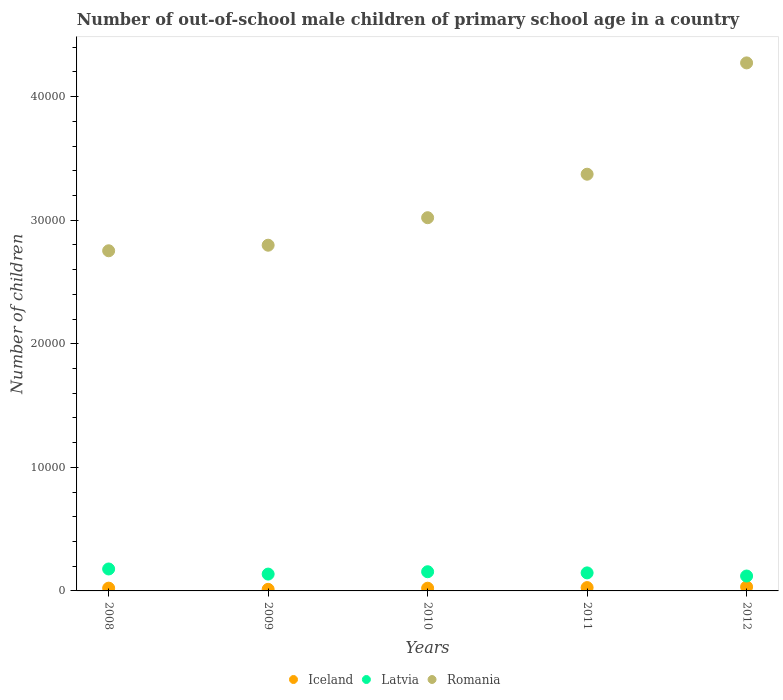Is the number of dotlines equal to the number of legend labels?
Ensure brevity in your answer.  Yes. What is the number of out-of-school male children in Latvia in 2011?
Make the answer very short. 1459. Across all years, what is the maximum number of out-of-school male children in Iceland?
Offer a terse response. 327. Across all years, what is the minimum number of out-of-school male children in Romania?
Offer a very short reply. 2.75e+04. In which year was the number of out-of-school male children in Iceland maximum?
Your response must be concise. 2012. In which year was the number of out-of-school male children in Romania minimum?
Make the answer very short. 2008. What is the total number of out-of-school male children in Iceland in the graph?
Offer a terse response. 1170. What is the difference between the number of out-of-school male children in Romania in 2009 and that in 2012?
Give a very brief answer. -1.48e+04. What is the difference between the number of out-of-school male children in Romania in 2010 and the number of out-of-school male children in Latvia in 2009?
Ensure brevity in your answer.  2.88e+04. What is the average number of out-of-school male children in Iceland per year?
Ensure brevity in your answer.  234. In the year 2008, what is the difference between the number of out-of-school male children in Romania and number of out-of-school male children in Iceland?
Your response must be concise. 2.73e+04. What is the ratio of the number of out-of-school male children in Latvia in 2009 to that in 2010?
Your answer should be very brief. 0.88. Is the difference between the number of out-of-school male children in Romania in 2009 and 2010 greater than the difference between the number of out-of-school male children in Iceland in 2009 and 2010?
Offer a very short reply. No. What is the difference between the highest and the second highest number of out-of-school male children in Latvia?
Your answer should be very brief. 224. What is the difference between the highest and the lowest number of out-of-school male children in Iceland?
Your answer should be compact. 198. Does the number of out-of-school male children in Iceland monotonically increase over the years?
Your answer should be very brief. No. Is the number of out-of-school male children in Romania strictly less than the number of out-of-school male children in Iceland over the years?
Provide a succinct answer. No. How many dotlines are there?
Your answer should be very brief. 3. How many legend labels are there?
Make the answer very short. 3. How are the legend labels stacked?
Your answer should be very brief. Horizontal. What is the title of the graph?
Give a very brief answer. Number of out-of-school male children of primary school age in a country. What is the label or title of the Y-axis?
Provide a short and direct response. Number of children. What is the Number of children of Iceland in 2008?
Offer a terse response. 225. What is the Number of children in Latvia in 2008?
Your answer should be compact. 1776. What is the Number of children in Romania in 2008?
Your answer should be compact. 2.75e+04. What is the Number of children in Iceland in 2009?
Provide a succinct answer. 129. What is the Number of children in Latvia in 2009?
Your response must be concise. 1362. What is the Number of children of Romania in 2009?
Give a very brief answer. 2.80e+04. What is the Number of children in Iceland in 2010?
Your response must be concise. 219. What is the Number of children in Latvia in 2010?
Your response must be concise. 1552. What is the Number of children of Romania in 2010?
Keep it short and to the point. 3.02e+04. What is the Number of children in Iceland in 2011?
Offer a terse response. 270. What is the Number of children of Latvia in 2011?
Make the answer very short. 1459. What is the Number of children of Romania in 2011?
Make the answer very short. 3.37e+04. What is the Number of children of Iceland in 2012?
Provide a short and direct response. 327. What is the Number of children of Latvia in 2012?
Your answer should be compact. 1206. What is the Number of children of Romania in 2012?
Make the answer very short. 4.27e+04. Across all years, what is the maximum Number of children in Iceland?
Offer a very short reply. 327. Across all years, what is the maximum Number of children of Latvia?
Provide a short and direct response. 1776. Across all years, what is the maximum Number of children in Romania?
Give a very brief answer. 4.27e+04. Across all years, what is the minimum Number of children of Iceland?
Give a very brief answer. 129. Across all years, what is the minimum Number of children of Latvia?
Provide a short and direct response. 1206. Across all years, what is the minimum Number of children of Romania?
Keep it short and to the point. 2.75e+04. What is the total Number of children of Iceland in the graph?
Your answer should be compact. 1170. What is the total Number of children in Latvia in the graph?
Keep it short and to the point. 7355. What is the total Number of children of Romania in the graph?
Ensure brevity in your answer.  1.62e+05. What is the difference between the Number of children in Iceland in 2008 and that in 2009?
Give a very brief answer. 96. What is the difference between the Number of children of Latvia in 2008 and that in 2009?
Provide a short and direct response. 414. What is the difference between the Number of children of Romania in 2008 and that in 2009?
Provide a short and direct response. -450. What is the difference between the Number of children in Latvia in 2008 and that in 2010?
Your answer should be compact. 224. What is the difference between the Number of children of Romania in 2008 and that in 2010?
Provide a short and direct response. -2675. What is the difference between the Number of children of Iceland in 2008 and that in 2011?
Your response must be concise. -45. What is the difference between the Number of children in Latvia in 2008 and that in 2011?
Your response must be concise. 317. What is the difference between the Number of children in Romania in 2008 and that in 2011?
Offer a very short reply. -6195. What is the difference between the Number of children in Iceland in 2008 and that in 2012?
Keep it short and to the point. -102. What is the difference between the Number of children in Latvia in 2008 and that in 2012?
Provide a short and direct response. 570. What is the difference between the Number of children in Romania in 2008 and that in 2012?
Offer a very short reply. -1.52e+04. What is the difference between the Number of children of Iceland in 2009 and that in 2010?
Your response must be concise. -90. What is the difference between the Number of children in Latvia in 2009 and that in 2010?
Offer a very short reply. -190. What is the difference between the Number of children in Romania in 2009 and that in 2010?
Offer a terse response. -2225. What is the difference between the Number of children of Iceland in 2009 and that in 2011?
Offer a very short reply. -141. What is the difference between the Number of children of Latvia in 2009 and that in 2011?
Give a very brief answer. -97. What is the difference between the Number of children in Romania in 2009 and that in 2011?
Give a very brief answer. -5745. What is the difference between the Number of children of Iceland in 2009 and that in 2012?
Offer a terse response. -198. What is the difference between the Number of children of Latvia in 2009 and that in 2012?
Ensure brevity in your answer.  156. What is the difference between the Number of children in Romania in 2009 and that in 2012?
Give a very brief answer. -1.48e+04. What is the difference between the Number of children of Iceland in 2010 and that in 2011?
Offer a very short reply. -51. What is the difference between the Number of children in Latvia in 2010 and that in 2011?
Ensure brevity in your answer.  93. What is the difference between the Number of children in Romania in 2010 and that in 2011?
Provide a succinct answer. -3520. What is the difference between the Number of children in Iceland in 2010 and that in 2012?
Your answer should be compact. -108. What is the difference between the Number of children in Latvia in 2010 and that in 2012?
Ensure brevity in your answer.  346. What is the difference between the Number of children in Romania in 2010 and that in 2012?
Offer a very short reply. -1.25e+04. What is the difference between the Number of children in Iceland in 2011 and that in 2012?
Make the answer very short. -57. What is the difference between the Number of children in Latvia in 2011 and that in 2012?
Your answer should be very brief. 253. What is the difference between the Number of children of Romania in 2011 and that in 2012?
Keep it short and to the point. -9007. What is the difference between the Number of children of Iceland in 2008 and the Number of children of Latvia in 2009?
Offer a very short reply. -1137. What is the difference between the Number of children in Iceland in 2008 and the Number of children in Romania in 2009?
Make the answer very short. -2.77e+04. What is the difference between the Number of children of Latvia in 2008 and the Number of children of Romania in 2009?
Provide a succinct answer. -2.62e+04. What is the difference between the Number of children of Iceland in 2008 and the Number of children of Latvia in 2010?
Make the answer very short. -1327. What is the difference between the Number of children in Iceland in 2008 and the Number of children in Romania in 2010?
Provide a succinct answer. -3.00e+04. What is the difference between the Number of children of Latvia in 2008 and the Number of children of Romania in 2010?
Your response must be concise. -2.84e+04. What is the difference between the Number of children of Iceland in 2008 and the Number of children of Latvia in 2011?
Offer a very short reply. -1234. What is the difference between the Number of children of Iceland in 2008 and the Number of children of Romania in 2011?
Your response must be concise. -3.35e+04. What is the difference between the Number of children in Latvia in 2008 and the Number of children in Romania in 2011?
Make the answer very short. -3.19e+04. What is the difference between the Number of children in Iceland in 2008 and the Number of children in Latvia in 2012?
Your answer should be very brief. -981. What is the difference between the Number of children in Iceland in 2008 and the Number of children in Romania in 2012?
Provide a short and direct response. -4.25e+04. What is the difference between the Number of children in Latvia in 2008 and the Number of children in Romania in 2012?
Your answer should be compact. -4.10e+04. What is the difference between the Number of children in Iceland in 2009 and the Number of children in Latvia in 2010?
Ensure brevity in your answer.  -1423. What is the difference between the Number of children of Iceland in 2009 and the Number of children of Romania in 2010?
Keep it short and to the point. -3.01e+04. What is the difference between the Number of children of Latvia in 2009 and the Number of children of Romania in 2010?
Ensure brevity in your answer.  -2.88e+04. What is the difference between the Number of children of Iceland in 2009 and the Number of children of Latvia in 2011?
Give a very brief answer. -1330. What is the difference between the Number of children in Iceland in 2009 and the Number of children in Romania in 2011?
Your answer should be compact. -3.36e+04. What is the difference between the Number of children in Latvia in 2009 and the Number of children in Romania in 2011?
Ensure brevity in your answer.  -3.24e+04. What is the difference between the Number of children of Iceland in 2009 and the Number of children of Latvia in 2012?
Ensure brevity in your answer.  -1077. What is the difference between the Number of children of Iceland in 2009 and the Number of children of Romania in 2012?
Keep it short and to the point. -4.26e+04. What is the difference between the Number of children in Latvia in 2009 and the Number of children in Romania in 2012?
Make the answer very short. -4.14e+04. What is the difference between the Number of children of Iceland in 2010 and the Number of children of Latvia in 2011?
Make the answer very short. -1240. What is the difference between the Number of children in Iceland in 2010 and the Number of children in Romania in 2011?
Make the answer very short. -3.35e+04. What is the difference between the Number of children of Latvia in 2010 and the Number of children of Romania in 2011?
Offer a terse response. -3.22e+04. What is the difference between the Number of children of Iceland in 2010 and the Number of children of Latvia in 2012?
Provide a succinct answer. -987. What is the difference between the Number of children in Iceland in 2010 and the Number of children in Romania in 2012?
Provide a short and direct response. -4.25e+04. What is the difference between the Number of children of Latvia in 2010 and the Number of children of Romania in 2012?
Offer a terse response. -4.12e+04. What is the difference between the Number of children of Iceland in 2011 and the Number of children of Latvia in 2012?
Offer a terse response. -936. What is the difference between the Number of children in Iceland in 2011 and the Number of children in Romania in 2012?
Give a very brief answer. -4.25e+04. What is the difference between the Number of children of Latvia in 2011 and the Number of children of Romania in 2012?
Your response must be concise. -4.13e+04. What is the average Number of children in Iceland per year?
Keep it short and to the point. 234. What is the average Number of children of Latvia per year?
Keep it short and to the point. 1471. What is the average Number of children in Romania per year?
Provide a short and direct response. 3.24e+04. In the year 2008, what is the difference between the Number of children of Iceland and Number of children of Latvia?
Your answer should be compact. -1551. In the year 2008, what is the difference between the Number of children of Iceland and Number of children of Romania?
Keep it short and to the point. -2.73e+04. In the year 2008, what is the difference between the Number of children of Latvia and Number of children of Romania?
Ensure brevity in your answer.  -2.57e+04. In the year 2009, what is the difference between the Number of children of Iceland and Number of children of Latvia?
Make the answer very short. -1233. In the year 2009, what is the difference between the Number of children in Iceland and Number of children in Romania?
Ensure brevity in your answer.  -2.78e+04. In the year 2009, what is the difference between the Number of children in Latvia and Number of children in Romania?
Give a very brief answer. -2.66e+04. In the year 2010, what is the difference between the Number of children of Iceland and Number of children of Latvia?
Keep it short and to the point. -1333. In the year 2010, what is the difference between the Number of children of Iceland and Number of children of Romania?
Your answer should be compact. -3.00e+04. In the year 2010, what is the difference between the Number of children of Latvia and Number of children of Romania?
Offer a very short reply. -2.86e+04. In the year 2011, what is the difference between the Number of children of Iceland and Number of children of Latvia?
Provide a succinct answer. -1189. In the year 2011, what is the difference between the Number of children of Iceland and Number of children of Romania?
Offer a very short reply. -3.34e+04. In the year 2011, what is the difference between the Number of children of Latvia and Number of children of Romania?
Provide a succinct answer. -3.23e+04. In the year 2012, what is the difference between the Number of children of Iceland and Number of children of Latvia?
Make the answer very short. -879. In the year 2012, what is the difference between the Number of children in Iceland and Number of children in Romania?
Your answer should be very brief. -4.24e+04. In the year 2012, what is the difference between the Number of children of Latvia and Number of children of Romania?
Provide a short and direct response. -4.15e+04. What is the ratio of the Number of children of Iceland in 2008 to that in 2009?
Ensure brevity in your answer.  1.74. What is the ratio of the Number of children in Latvia in 2008 to that in 2009?
Your answer should be very brief. 1.3. What is the ratio of the Number of children in Romania in 2008 to that in 2009?
Provide a succinct answer. 0.98. What is the ratio of the Number of children in Iceland in 2008 to that in 2010?
Provide a short and direct response. 1.03. What is the ratio of the Number of children of Latvia in 2008 to that in 2010?
Your answer should be very brief. 1.14. What is the ratio of the Number of children in Romania in 2008 to that in 2010?
Your response must be concise. 0.91. What is the ratio of the Number of children of Iceland in 2008 to that in 2011?
Keep it short and to the point. 0.83. What is the ratio of the Number of children in Latvia in 2008 to that in 2011?
Your answer should be compact. 1.22. What is the ratio of the Number of children in Romania in 2008 to that in 2011?
Make the answer very short. 0.82. What is the ratio of the Number of children in Iceland in 2008 to that in 2012?
Your answer should be compact. 0.69. What is the ratio of the Number of children in Latvia in 2008 to that in 2012?
Offer a very short reply. 1.47. What is the ratio of the Number of children in Romania in 2008 to that in 2012?
Offer a terse response. 0.64. What is the ratio of the Number of children in Iceland in 2009 to that in 2010?
Offer a terse response. 0.59. What is the ratio of the Number of children in Latvia in 2009 to that in 2010?
Your answer should be very brief. 0.88. What is the ratio of the Number of children in Romania in 2009 to that in 2010?
Keep it short and to the point. 0.93. What is the ratio of the Number of children of Iceland in 2009 to that in 2011?
Offer a terse response. 0.48. What is the ratio of the Number of children in Latvia in 2009 to that in 2011?
Make the answer very short. 0.93. What is the ratio of the Number of children in Romania in 2009 to that in 2011?
Provide a short and direct response. 0.83. What is the ratio of the Number of children in Iceland in 2009 to that in 2012?
Ensure brevity in your answer.  0.39. What is the ratio of the Number of children of Latvia in 2009 to that in 2012?
Provide a short and direct response. 1.13. What is the ratio of the Number of children of Romania in 2009 to that in 2012?
Your response must be concise. 0.65. What is the ratio of the Number of children of Iceland in 2010 to that in 2011?
Make the answer very short. 0.81. What is the ratio of the Number of children of Latvia in 2010 to that in 2011?
Provide a succinct answer. 1.06. What is the ratio of the Number of children of Romania in 2010 to that in 2011?
Provide a succinct answer. 0.9. What is the ratio of the Number of children of Iceland in 2010 to that in 2012?
Give a very brief answer. 0.67. What is the ratio of the Number of children of Latvia in 2010 to that in 2012?
Your answer should be very brief. 1.29. What is the ratio of the Number of children of Romania in 2010 to that in 2012?
Ensure brevity in your answer.  0.71. What is the ratio of the Number of children in Iceland in 2011 to that in 2012?
Give a very brief answer. 0.83. What is the ratio of the Number of children in Latvia in 2011 to that in 2012?
Offer a very short reply. 1.21. What is the ratio of the Number of children of Romania in 2011 to that in 2012?
Offer a very short reply. 0.79. What is the difference between the highest and the second highest Number of children in Latvia?
Give a very brief answer. 224. What is the difference between the highest and the second highest Number of children in Romania?
Make the answer very short. 9007. What is the difference between the highest and the lowest Number of children in Iceland?
Make the answer very short. 198. What is the difference between the highest and the lowest Number of children of Latvia?
Provide a succinct answer. 570. What is the difference between the highest and the lowest Number of children in Romania?
Provide a short and direct response. 1.52e+04. 